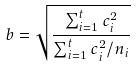Convert formula to latex. <formula><loc_0><loc_0><loc_500><loc_500>b = \sqrt { \frac { \sum _ { i = 1 } ^ { t } c _ { i } ^ { 2 } } { \sum _ { i = 1 } ^ { t } c _ { i } ^ { 2 } / n _ { i } } }</formula> 